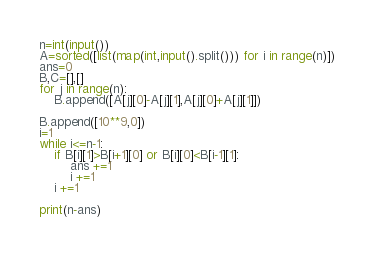<code> <loc_0><loc_0><loc_500><loc_500><_Python_>n=int(input())
A=sorted([list(map(int,input().split())) for i in range(n)])
ans=0
B,C=[],[]
for j in range(n):
    B.append([A[j][0]-A[j][1],A[j][0]+A[j][1]])

B.append([10**9,0])
i=1
while i<=n-1:
    if B[i][1]>B[i+1][0] or B[i][0]<B[i-1][1]:
        ans +=1
        i +=1
    i +=1

print(n-ans)</code> 